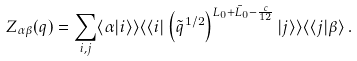<formula> <loc_0><loc_0><loc_500><loc_500>Z _ { \alpha \beta } ( q ) = \sum _ { i , j } \langle \alpha | i \rangle \rangle \langle \langle i | \left ( \tilde { q } ^ { 1 / 2 } \right ) ^ { L _ { 0 } + \bar { L } _ { 0 } - \frac { c } { 1 2 } } | j \rangle \rangle \langle \langle j | \beta \rangle \, .</formula> 